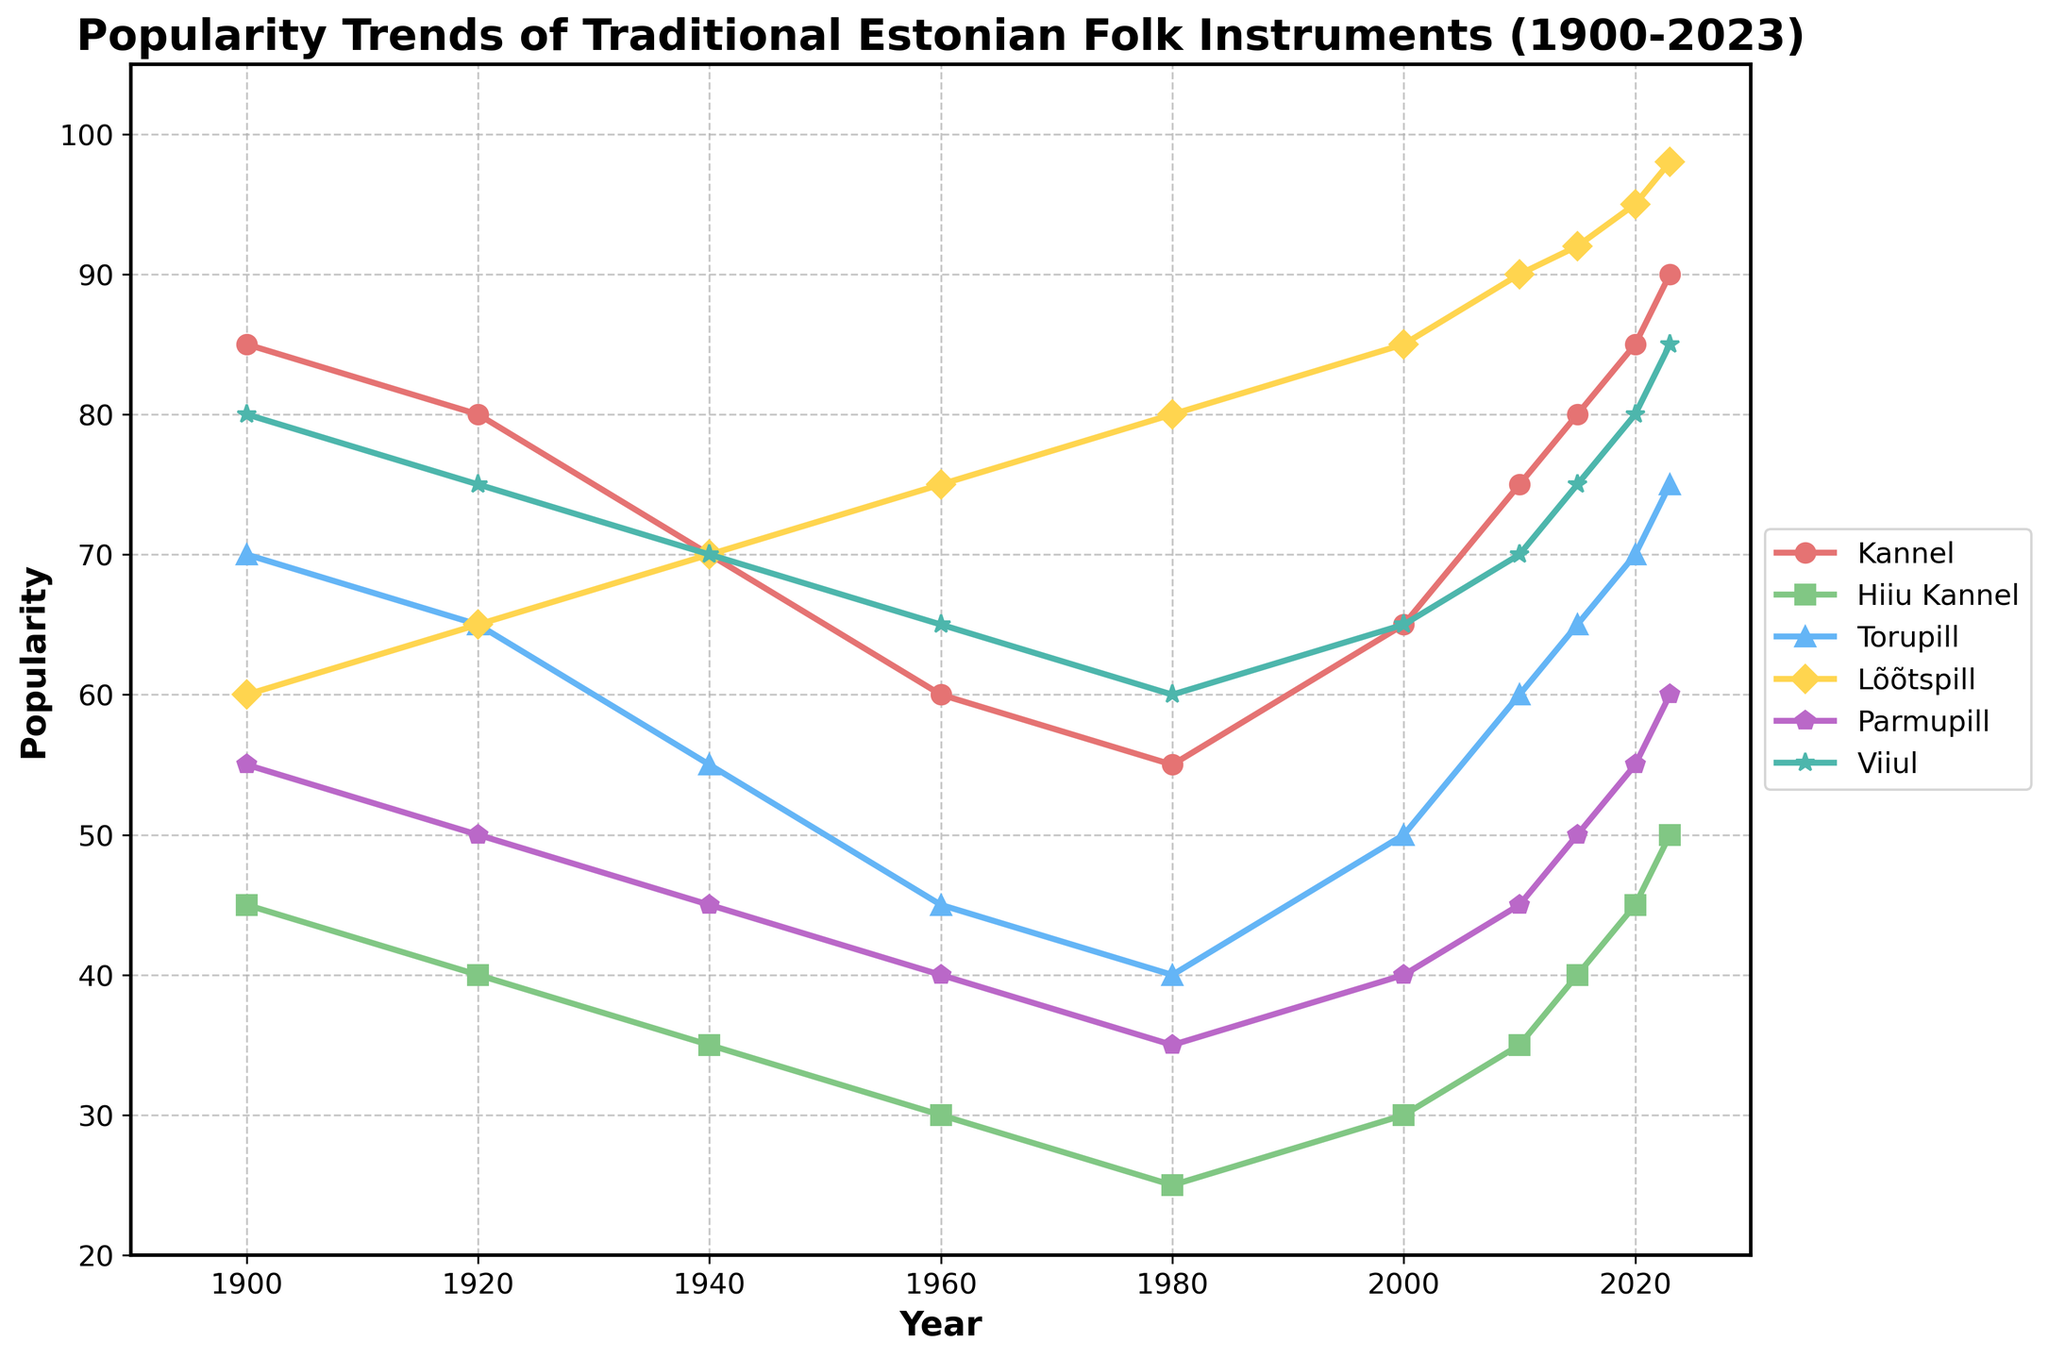What trend can be observed in the popularity of the Kannel from 1900 to 2023? By looking at the line for the Kannel (cyan color), it's clear that there has been a general increase in popularity from around 85 in 1900 to 90 in 2023. This suggests a long-term upward trend in its popularity.
Answer: Increasing trend Which instrument shows the highest popularity in the year 2023 and what is its popularity value? In 2023, by observing the heights of the lines, the Lõõtspill (orange color) shows the highest value at 98. This can be seen as its line is the tallest on the plot for this year.
Answer: Lõõtspill, 98 How did the popularity of the Hiiu Kannel change from 1980 to 2023? Observing the green line for Hiiu Kannel, we see an ascent from 25 in 1980 to 50 in 2023. This indicates a significant increase in its popularity over this period.
Answer: Increased from 25 to 50 Between 1950 and 2000, which instrument saw the greatest increase in popularity? Comparing the lines between the years 1950 and 2000, Lõõtspill's popularity increased from 70 to 85, a 15-point increase, which is greater than other instruments within the same timeframe.
Answer: Lõõtspill Which instrument had the least popularity in 1960 and what was its value? In 1960, the Hiiu Kannel (green line) appears to be at the bottom compared to other instruments, with a value of 30.
Answer: Hiiu Kannel, 30 Compare the popularity changes of Torupill and Viiul from 2010 to 2023. Which one increased more? From 2010 to 2023, Torupill (blue line) increased from 60 to 75, a 15-point rise, and Viiul (purple line) increased from 70 to 85, similarly a 15-point rise. Therefore, both had the same increase.
Answer: Both increased by 15 Which decade shows the sharpest increase in the popularity of the Parmupill? Observing the line plot for Parmupill (green color), the sharpest increase appears to be between the years 2000 and 2010, ascending from 40 to 45.
Answer: 2000-2010 Which instrument showed a declining trend in popularity from 1900 to 1980, and what was the difference? The Hiiu Kannel (green line) showed a declining trend from 45 in 1900 to 25 in 1980, a 20-point decrease.
Answer: Hiiu Kannel, 20 Between 2000 and 2015, did any instrument's popularity remain unchanged? If yes, which one? Analyzing the lines between the years 2000 and 2015, none of the instruments remained unchanged in their popularity.
Answer: No instrument remained unchanged 